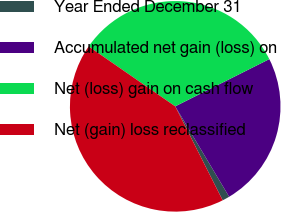Convert chart to OTSL. <chart><loc_0><loc_0><loc_500><loc_500><pie_chart><fcel>Year Ended December 31<fcel>Accumulated net gain (loss) on<fcel>Net (loss) gain on cash flow<fcel>Net (gain) loss reclassified<nl><fcel>1.12%<fcel>23.84%<fcel>32.96%<fcel>42.08%<nl></chart> 